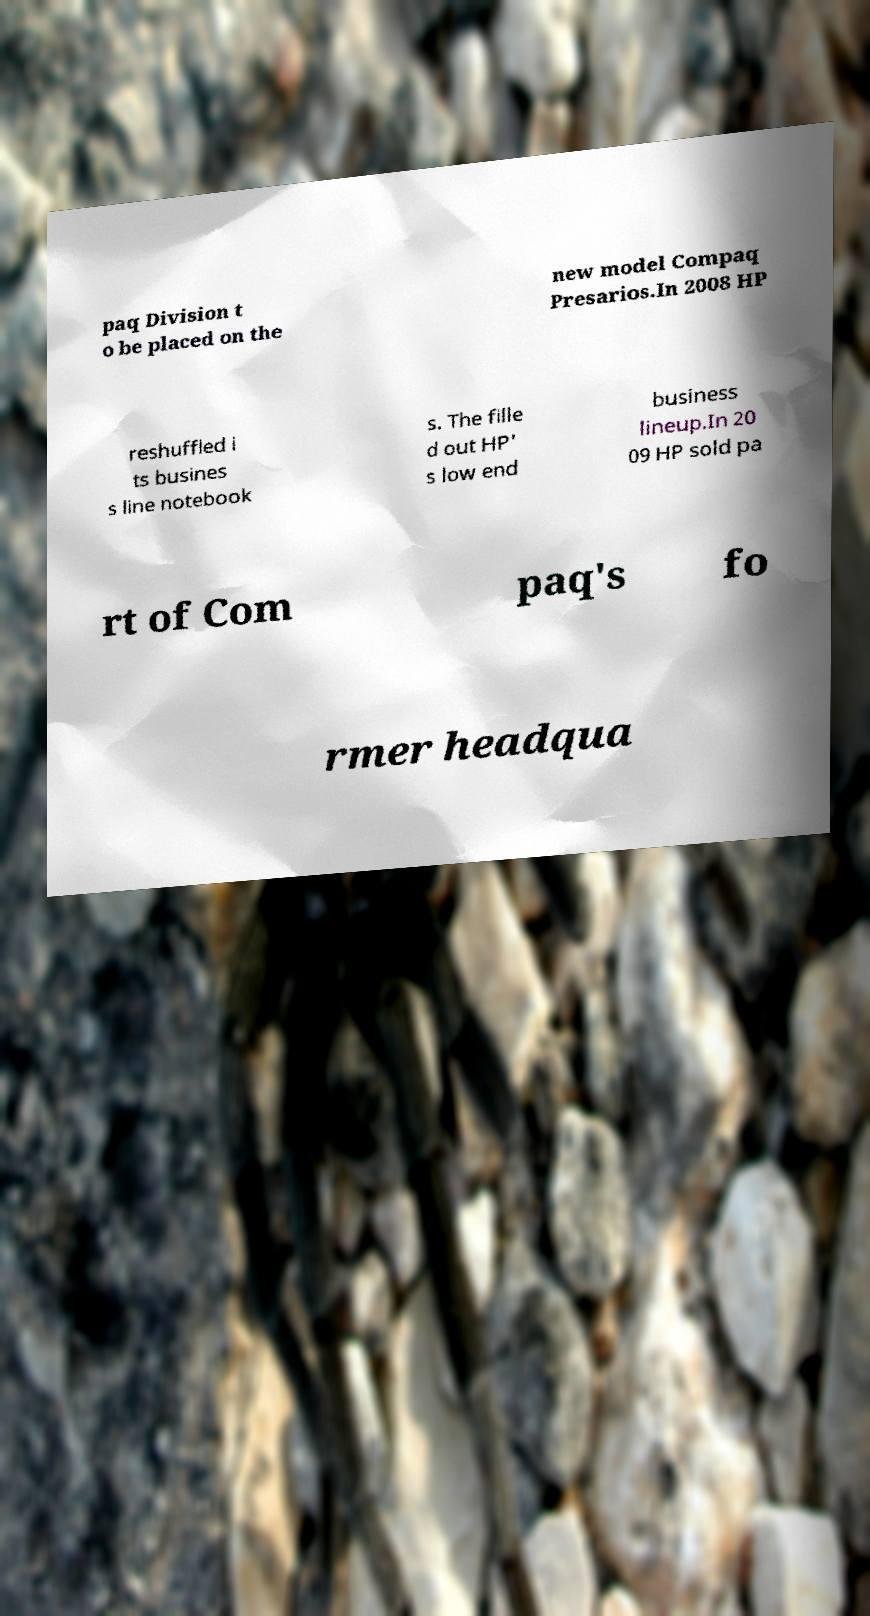Can you accurately transcribe the text from the provided image for me? paq Division t o be placed on the new model Compaq Presarios.In 2008 HP reshuffled i ts busines s line notebook s. The fille d out HP' s low end business lineup.In 20 09 HP sold pa rt of Com paq's fo rmer headqua 